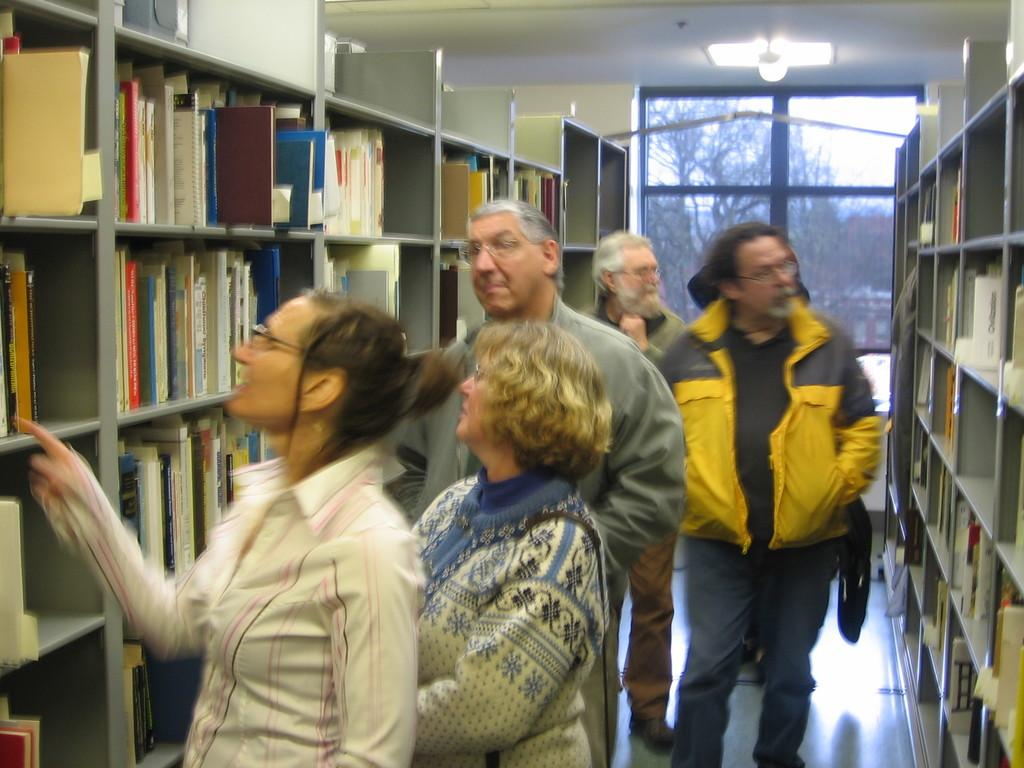What is the main subject of the image? The main subject of the image is a group of people. What can be seen in the background of the image? There is a light and trees in the background of the image. What type of objects are present in the image? There are books in the racks in the image. What type of bread can be seen on the table in the image? There is no bread present in the image. What color is the paint on the wall in the image? There is no paint visible on any walls in the image. 